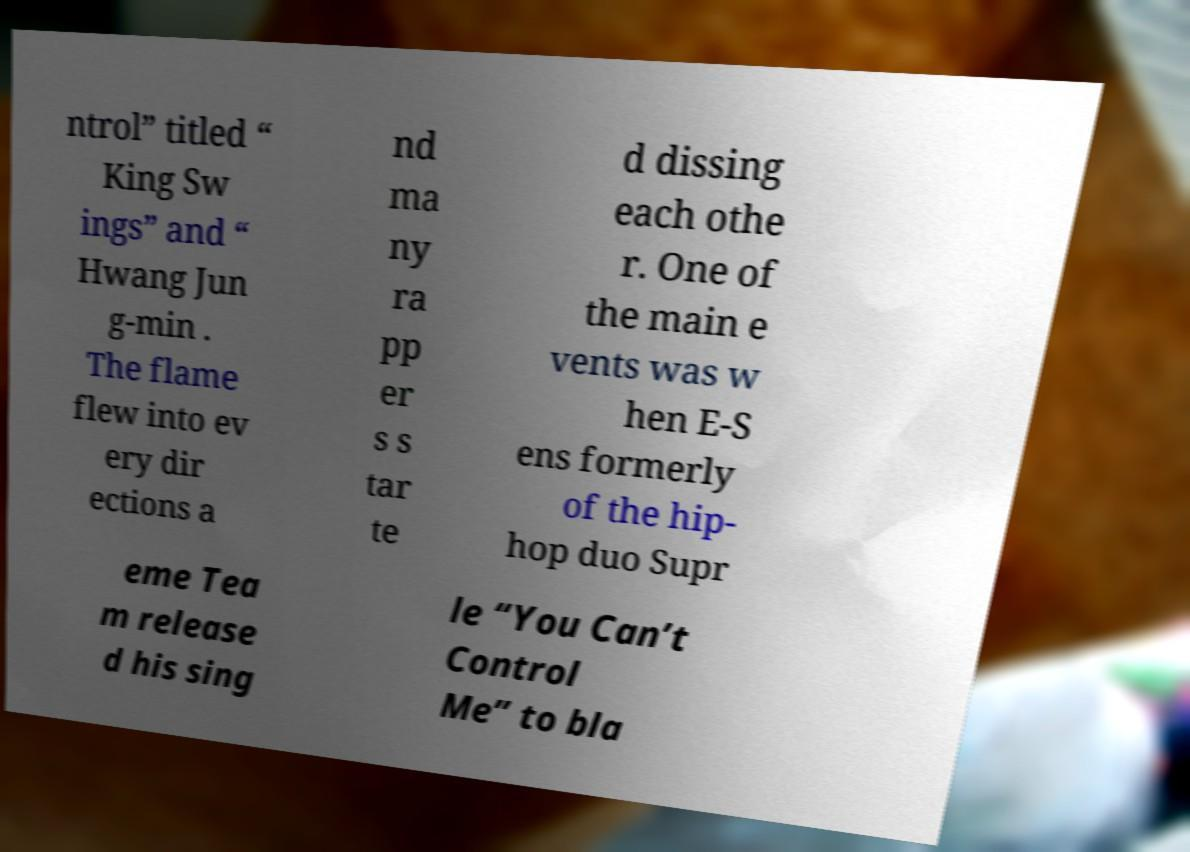Could you assist in decoding the text presented in this image and type it out clearly? ntrol” titled “ King Sw ings” and “ Hwang Jun g-min . The flame flew into ev ery dir ections a nd ma ny ra pp er s s tar te d dissing each othe r. One of the main e vents was w hen E-S ens formerly of the hip- hop duo Supr eme Tea m release d his sing le “You Can’t Control Me” to bla 